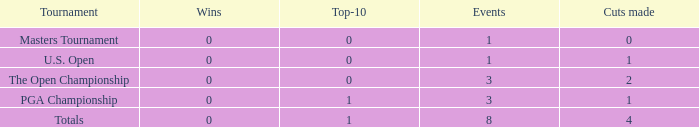For events with values of exactly 1, and 0 cuts made, what is the fewest number of top-10s? 0.0. 